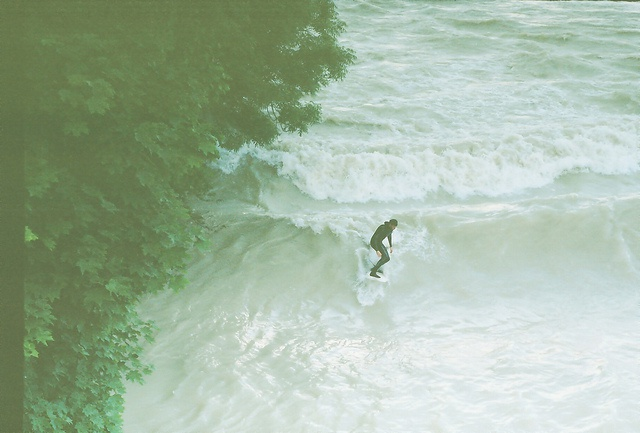Describe the objects in this image and their specific colors. I can see people in olive, gray, darkgray, and ivory tones and surfboard in olive, lightgray, lightblue, and darkgray tones in this image. 